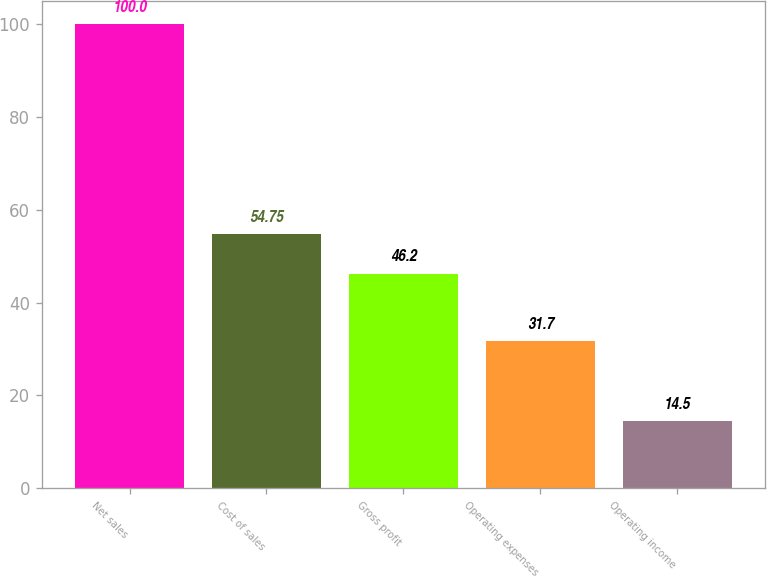<chart> <loc_0><loc_0><loc_500><loc_500><bar_chart><fcel>Net sales<fcel>Cost of sales<fcel>Gross profit<fcel>Operating expenses<fcel>Operating income<nl><fcel>100<fcel>54.75<fcel>46.2<fcel>31.7<fcel>14.5<nl></chart> 